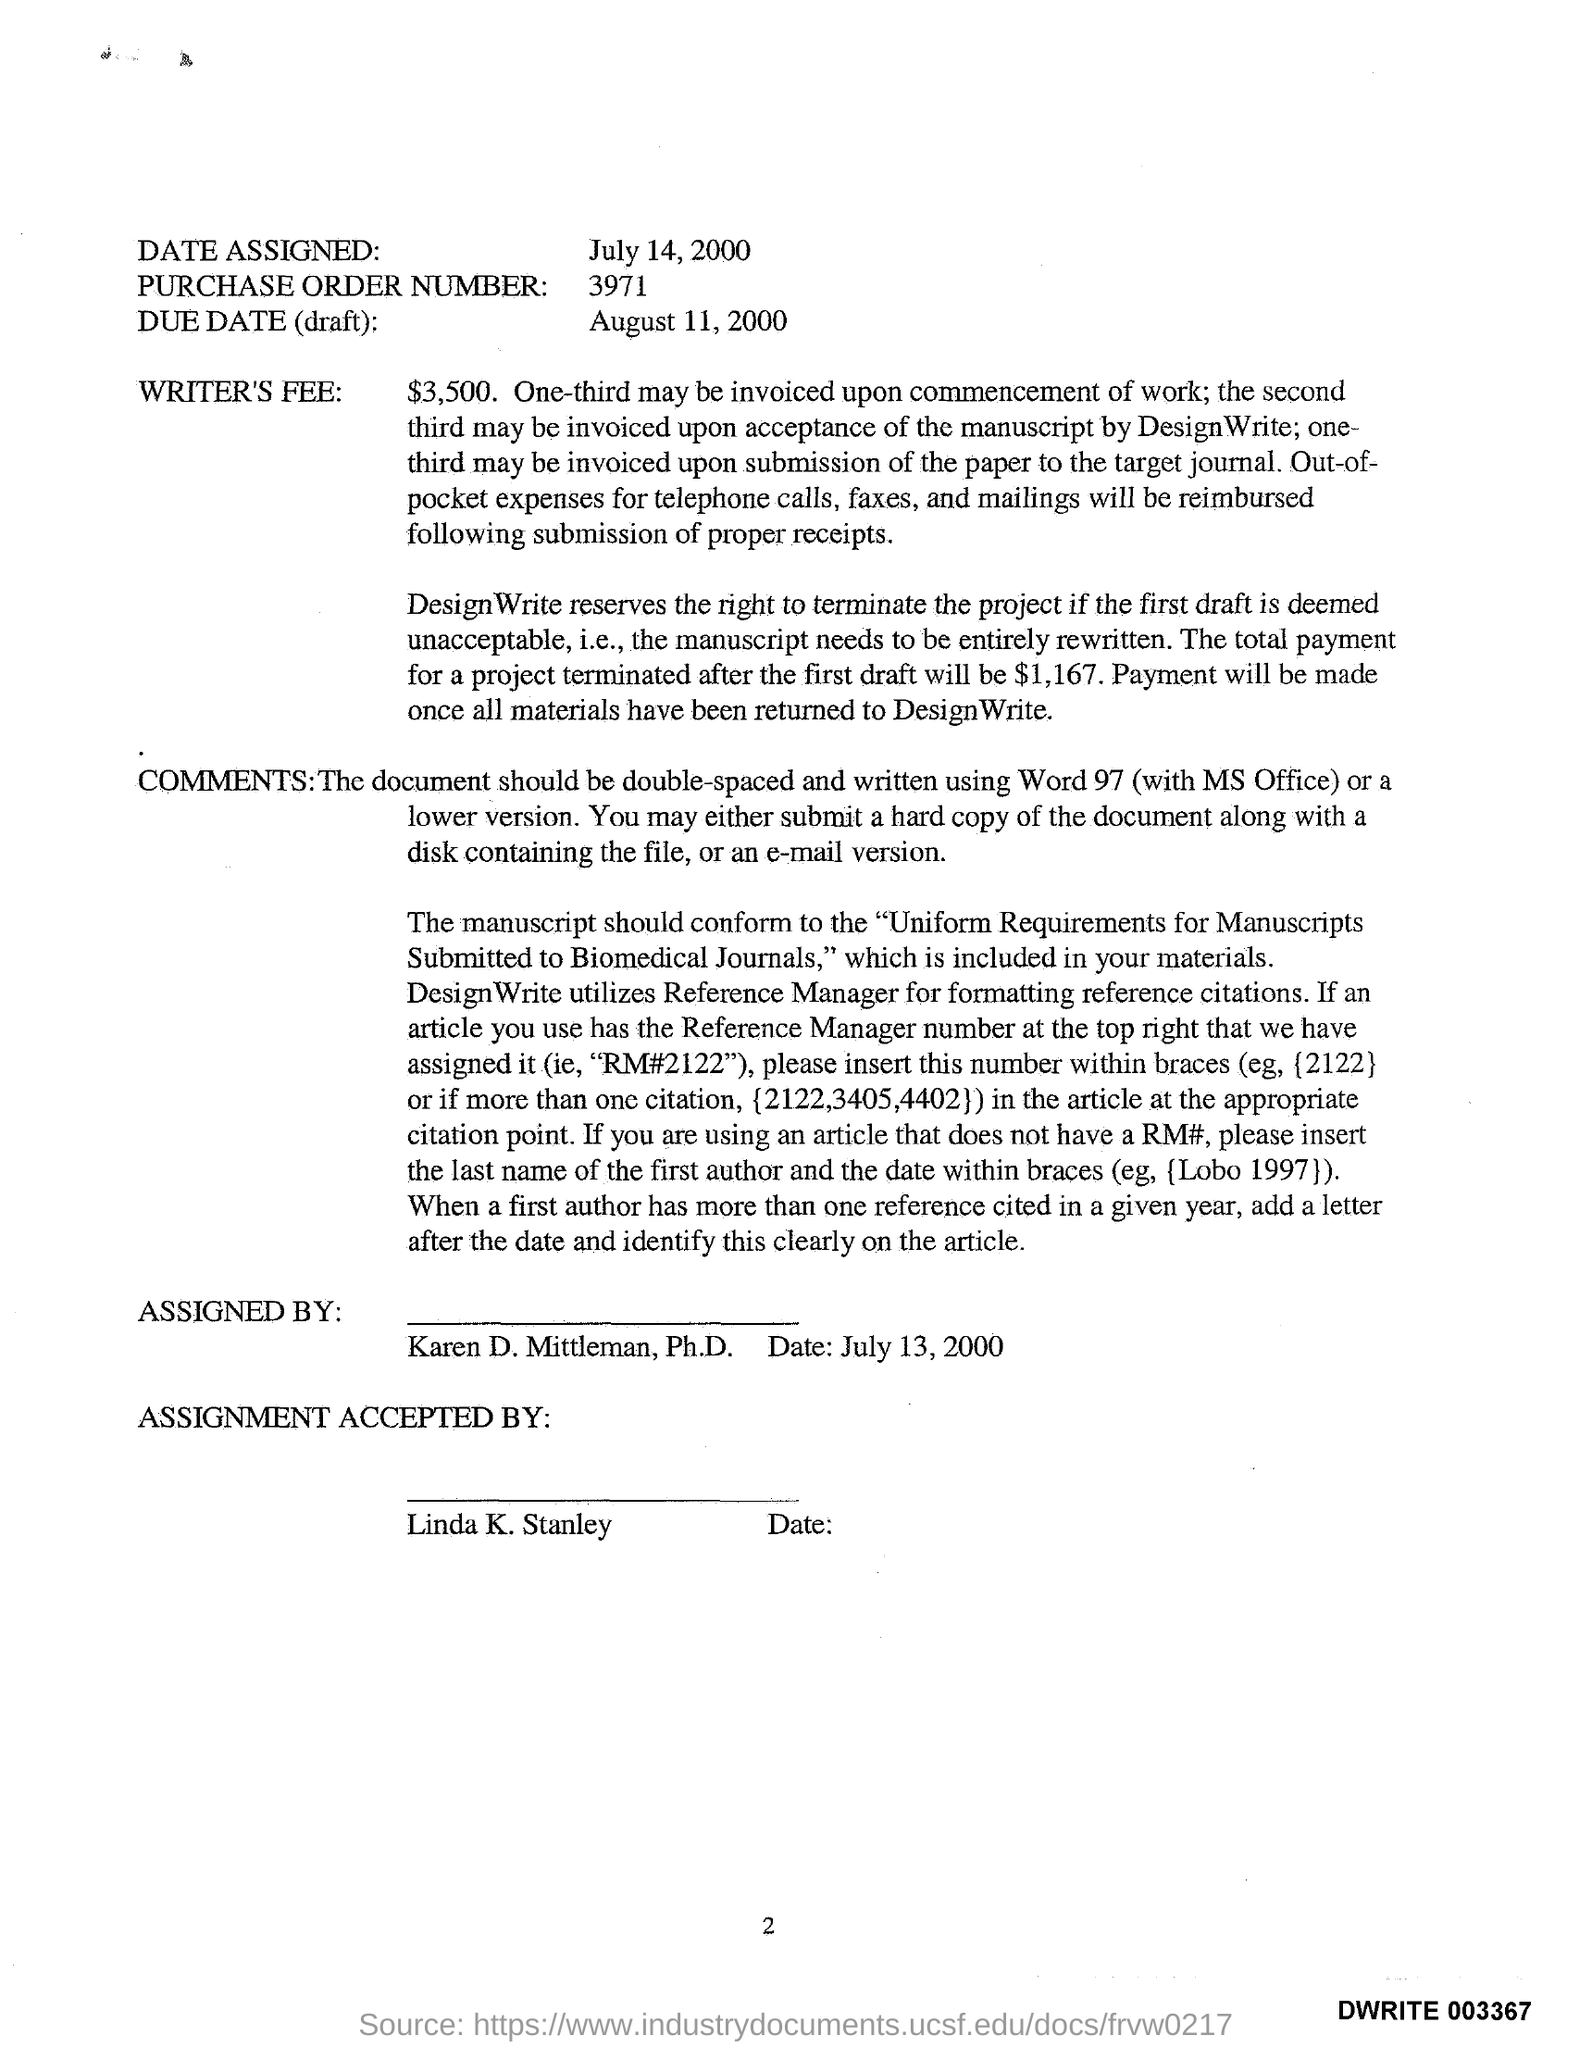What is the writer's fee mentioned in the given letter ?
Provide a succinct answer. $ 3,500. Who's name was written under the assigned by column in the given letter ?
Provide a short and direct response. Karen D. Mittleman. By whom the assignment accepted by in the given letter ?
Offer a terse response. Linda K. Stanley. 